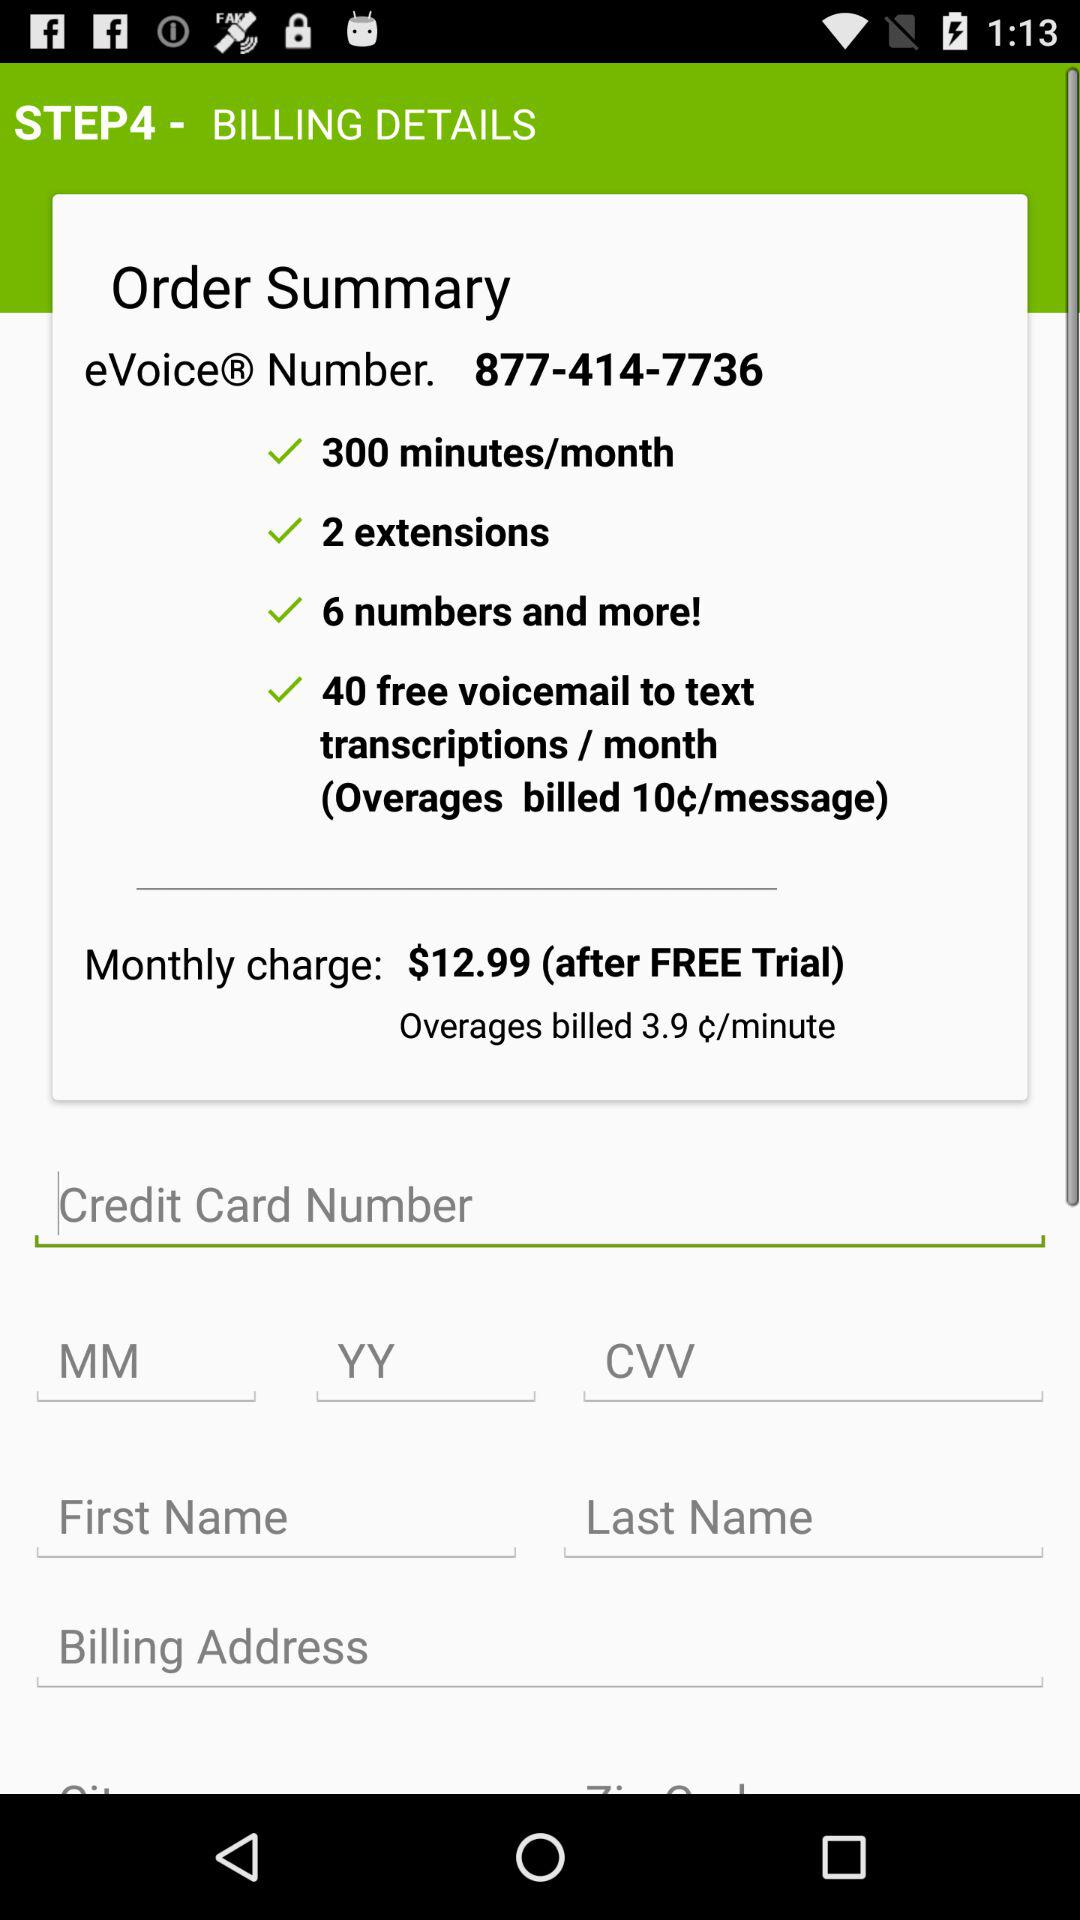How many extensions are there? There are 2 extensions. 